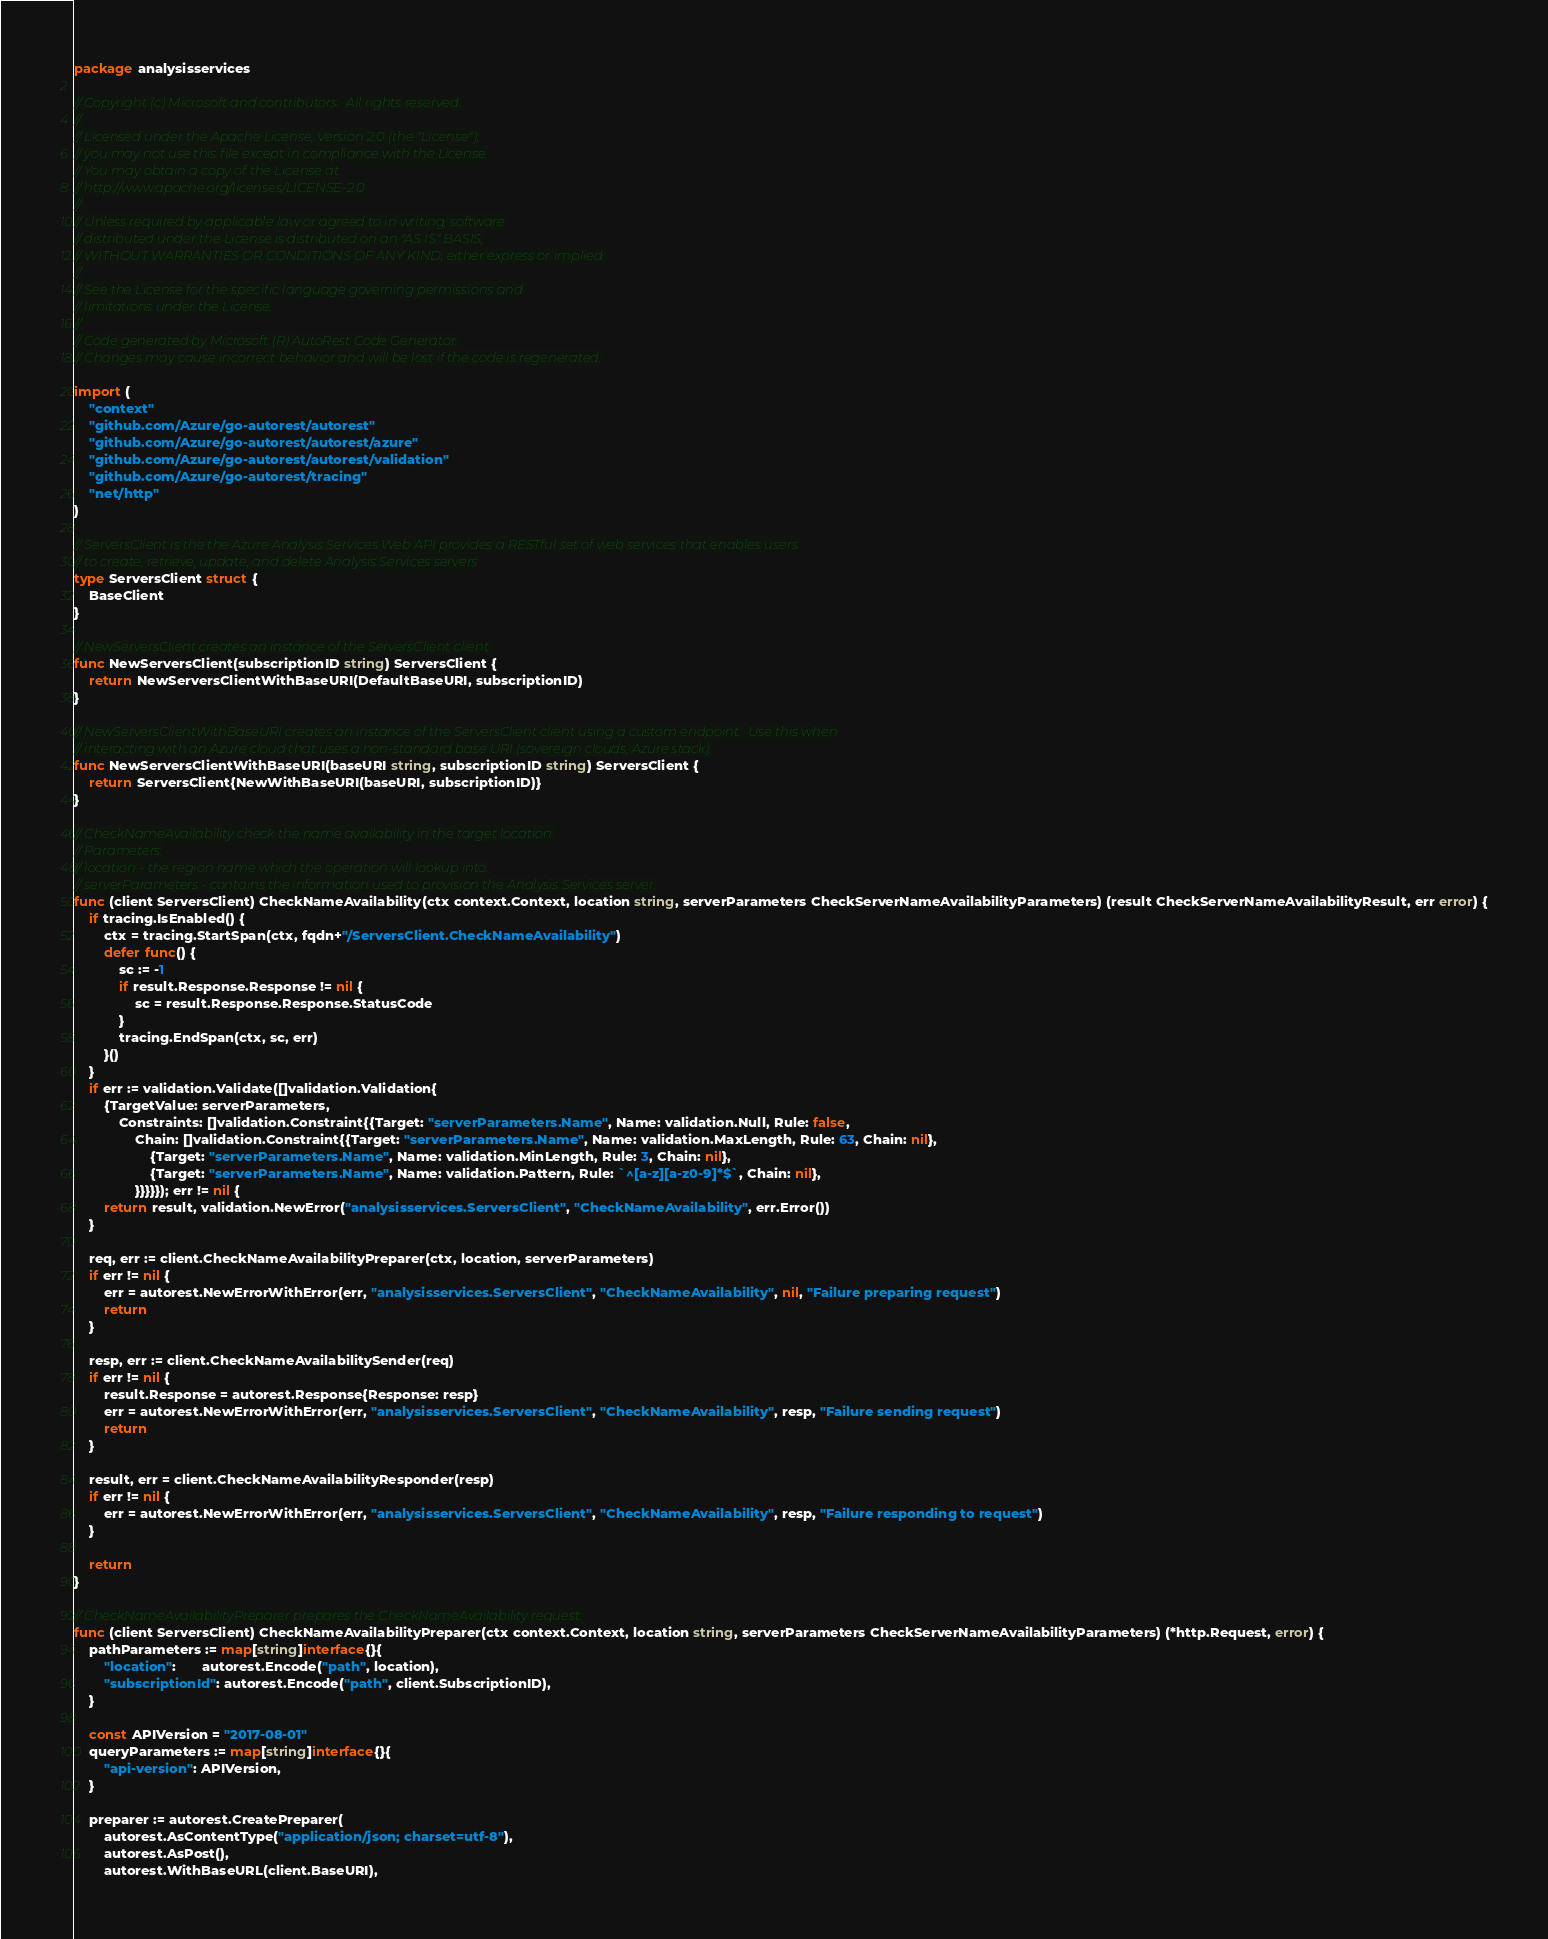<code> <loc_0><loc_0><loc_500><loc_500><_Go_>package analysisservices

// Copyright (c) Microsoft and contributors.  All rights reserved.
//
// Licensed under the Apache License, Version 2.0 (the "License");
// you may not use this file except in compliance with the License.
// You may obtain a copy of the License at
// http://www.apache.org/licenses/LICENSE-2.0
//
// Unless required by applicable law or agreed to in writing, software
// distributed under the License is distributed on an "AS IS" BASIS,
// WITHOUT WARRANTIES OR CONDITIONS OF ANY KIND, either express or implied.
//
// See the License for the specific language governing permissions and
// limitations under the License.
//
// Code generated by Microsoft (R) AutoRest Code Generator.
// Changes may cause incorrect behavior and will be lost if the code is regenerated.

import (
	"context"
	"github.com/Azure/go-autorest/autorest"
	"github.com/Azure/go-autorest/autorest/azure"
	"github.com/Azure/go-autorest/autorest/validation"
	"github.com/Azure/go-autorest/tracing"
	"net/http"
)

// ServersClient is the the Azure Analysis Services Web API provides a RESTful set of web services that enables users
// to create, retrieve, update, and delete Analysis Services servers
type ServersClient struct {
	BaseClient
}

// NewServersClient creates an instance of the ServersClient client.
func NewServersClient(subscriptionID string) ServersClient {
	return NewServersClientWithBaseURI(DefaultBaseURI, subscriptionID)
}

// NewServersClientWithBaseURI creates an instance of the ServersClient client using a custom endpoint.  Use this when
// interacting with an Azure cloud that uses a non-standard base URI (sovereign clouds, Azure stack).
func NewServersClientWithBaseURI(baseURI string, subscriptionID string) ServersClient {
	return ServersClient{NewWithBaseURI(baseURI, subscriptionID)}
}

// CheckNameAvailability check the name availability in the target location.
// Parameters:
// location - the region name which the operation will lookup into.
// serverParameters - contains the information used to provision the Analysis Services server.
func (client ServersClient) CheckNameAvailability(ctx context.Context, location string, serverParameters CheckServerNameAvailabilityParameters) (result CheckServerNameAvailabilityResult, err error) {
	if tracing.IsEnabled() {
		ctx = tracing.StartSpan(ctx, fqdn+"/ServersClient.CheckNameAvailability")
		defer func() {
			sc := -1
			if result.Response.Response != nil {
				sc = result.Response.Response.StatusCode
			}
			tracing.EndSpan(ctx, sc, err)
		}()
	}
	if err := validation.Validate([]validation.Validation{
		{TargetValue: serverParameters,
			Constraints: []validation.Constraint{{Target: "serverParameters.Name", Name: validation.Null, Rule: false,
				Chain: []validation.Constraint{{Target: "serverParameters.Name", Name: validation.MaxLength, Rule: 63, Chain: nil},
					{Target: "serverParameters.Name", Name: validation.MinLength, Rule: 3, Chain: nil},
					{Target: "serverParameters.Name", Name: validation.Pattern, Rule: `^[a-z][a-z0-9]*$`, Chain: nil},
				}}}}}); err != nil {
		return result, validation.NewError("analysisservices.ServersClient", "CheckNameAvailability", err.Error())
	}

	req, err := client.CheckNameAvailabilityPreparer(ctx, location, serverParameters)
	if err != nil {
		err = autorest.NewErrorWithError(err, "analysisservices.ServersClient", "CheckNameAvailability", nil, "Failure preparing request")
		return
	}

	resp, err := client.CheckNameAvailabilitySender(req)
	if err != nil {
		result.Response = autorest.Response{Response: resp}
		err = autorest.NewErrorWithError(err, "analysisservices.ServersClient", "CheckNameAvailability", resp, "Failure sending request")
		return
	}

	result, err = client.CheckNameAvailabilityResponder(resp)
	if err != nil {
		err = autorest.NewErrorWithError(err, "analysisservices.ServersClient", "CheckNameAvailability", resp, "Failure responding to request")
	}

	return
}

// CheckNameAvailabilityPreparer prepares the CheckNameAvailability request.
func (client ServersClient) CheckNameAvailabilityPreparer(ctx context.Context, location string, serverParameters CheckServerNameAvailabilityParameters) (*http.Request, error) {
	pathParameters := map[string]interface{}{
		"location":       autorest.Encode("path", location),
		"subscriptionId": autorest.Encode("path", client.SubscriptionID),
	}

	const APIVersion = "2017-08-01"
	queryParameters := map[string]interface{}{
		"api-version": APIVersion,
	}

	preparer := autorest.CreatePreparer(
		autorest.AsContentType("application/json; charset=utf-8"),
		autorest.AsPost(),
		autorest.WithBaseURL(client.BaseURI),</code> 